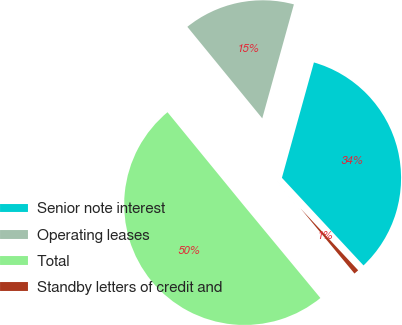<chart> <loc_0><loc_0><loc_500><loc_500><pie_chart><fcel>Senior note interest<fcel>Operating leases<fcel>Total<fcel>Standby letters of credit and<nl><fcel>33.76%<fcel>15.22%<fcel>50.09%<fcel>0.93%<nl></chart> 